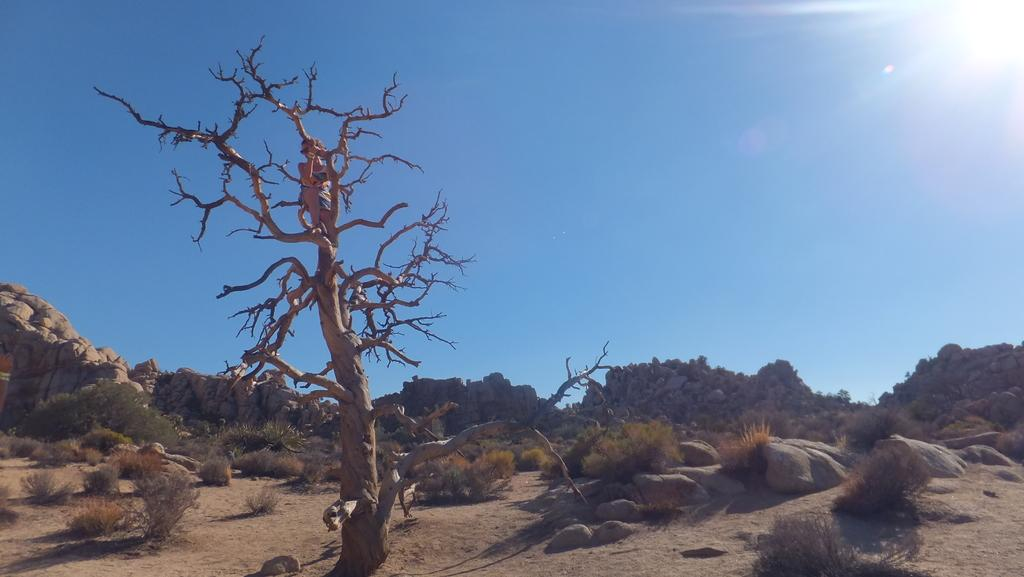What is the person in the image standing on? The person is standing on a dried tree. What can be seen in the background of the image? The background includes green grass and stones and rocks. What color is the sky in the image? The sky is blue in color. What type of pipe can be seen in the image? There is no pipe present in the image. How is the person using the paste in the image? There is no paste present in the image. 